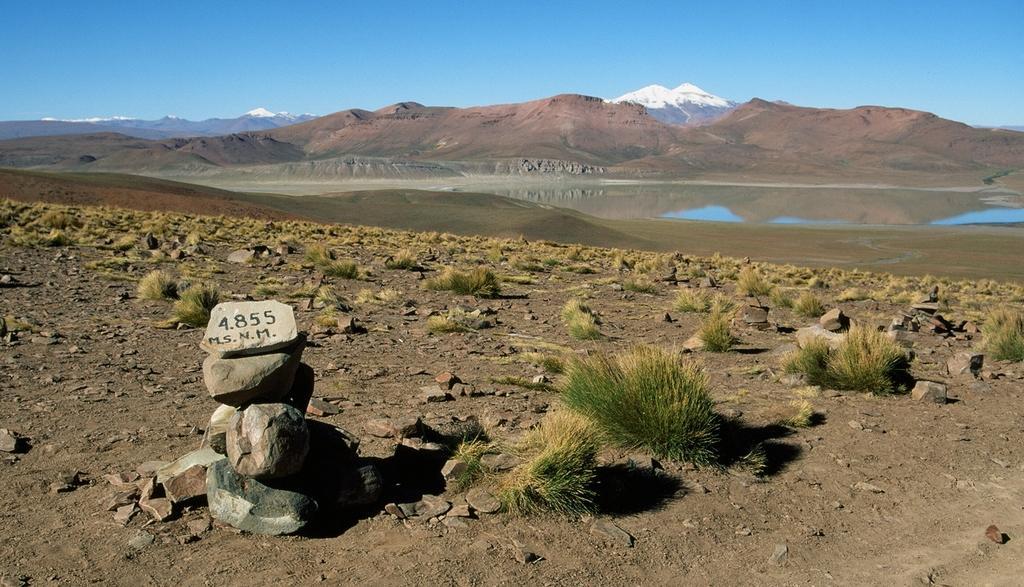Describe this image in one or two sentences. In this picture we can see some grass and a few stones. We can see some text and numbers on a stone. There is the water and some mountains covered with snow. We can see the sky on top. 